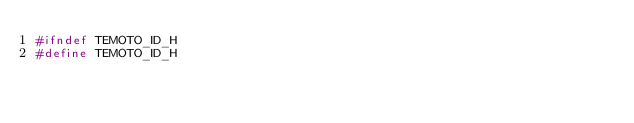Convert code to text. <code><loc_0><loc_0><loc_500><loc_500><_C_>#ifndef TEMOTO_ID_H
#define TEMOTO_ID_H
</code> 